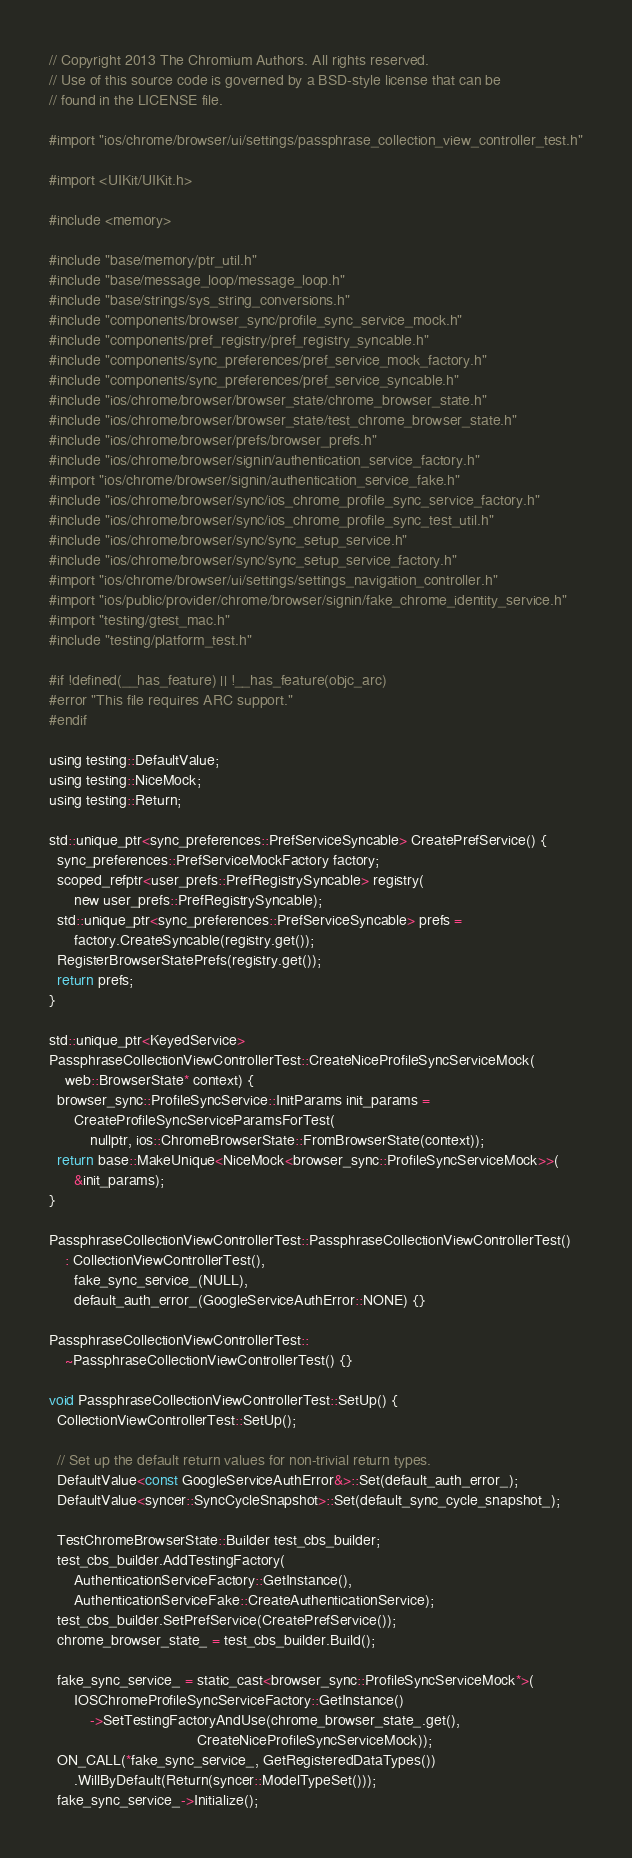<code> <loc_0><loc_0><loc_500><loc_500><_ObjectiveC_>// Copyright 2013 The Chromium Authors. All rights reserved.
// Use of this source code is governed by a BSD-style license that can be
// found in the LICENSE file.

#import "ios/chrome/browser/ui/settings/passphrase_collection_view_controller_test.h"

#import <UIKit/UIKit.h>

#include <memory>

#include "base/memory/ptr_util.h"
#include "base/message_loop/message_loop.h"
#include "base/strings/sys_string_conversions.h"
#include "components/browser_sync/profile_sync_service_mock.h"
#include "components/pref_registry/pref_registry_syncable.h"
#include "components/sync_preferences/pref_service_mock_factory.h"
#include "components/sync_preferences/pref_service_syncable.h"
#include "ios/chrome/browser/browser_state/chrome_browser_state.h"
#include "ios/chrome/browser/browser_state/test_chrome_browser_state.h"
#include "ios/chrome/browser/prefs/browser_prefs.h"
#include "ios/chrome/browser/signin/authentication_service_factory.h"
#import "ios/chrome/browser/signin/authentication_service_fake.h"
#include "ios/chrome/browser/sync/ios_chrome_profile_sync_service_factory.h"
#include "ios/chrome/browser/sync/ios_chrome_profile_sync_test_util.h"
#include "ios/chrome/browser/sync/sync_setup_service.h"
#include "ios/chrome/browser/sync/sync_setup_service_factory.h"
#import "ios/chrome/browser/ui/settings/settings_navigation_controller.h"
#import "ios/public/provider/chrome/browser/signin/fake_chrome_identity_service.h"
#import "testing/gtest_mac.h"
#include "testing/platform_test.h"

#if !defined(__has_feature) || !__has_feature(objc_arc)
#error "This file requires ARC support."
#endif

using testing::DefaultValue;
using testing::NiceMock;
using testing::Return;

std::unique_ptr<sync_preferences::PrefServiceSyncable> CreatePrefService() {
  sync_preferences::PrefServiceMockFactory factory;
  scoped_refptr<user_prefs::PrefRegistrySyncable> registry(
      new user_prefs::PrefRegistrySyncable);
  std::unique_ptr<sync_preferences::PrefServiceSyncable> prefs =
      factory.CreateSyncable(registry.get());
  RegisterBrowserStatePrefs(registry.get());
  return prefs;
}

std::unique_ptr<KeyedService>
PassphraseCollectionViewControllerTest::CreateNiceProfileSyncServiceMock(
    web::BrowserState* context) {
  browser_sync::ProfileSyncService::InitParams init_params =
      CreateProfileSyncServiceParamsForTest(
          nullptr, ios::ChromeBrowserState::FromBrowserState(context));
  return base::MakeUnique<NiceMock<browser_sync::ProfileSyncServiceMock>>(
      &init_params);
}

PassphraseCollectionViewControllerTest::PassphraseCollectionViewControllerTest()
    : CollectionViewControllerTest(),
      fake_sync_service_(NULL),
      default_auth_error_(GoogleServiceAuthError::NONE) {}

PassphraseCollectionViewControllerTest::
    ~PassphraseCollectionViewControllerTest() {}

void PassphraseCollectionViewControllerTest::SetUp() {
  CollectionViewControllerTest::SetUp();

  // Set up the default return values for non-trivial return types.
  DefaultValue<const GoogleServiceAuthError&>::Set(default_auth_error_);
  DefaultValue<syncer::SyncCycleSnapshot>::Set(default_sync_cycle_snapshot_);

  TestChromeBrowserState::Builder test_cbs_builder;
  test_cbs_builder.AddTestingFactory(
      AuthenticationServiceFactory::GetInstance(),
      AuthenticationServiceFake::CreateAuthenticationService);
  test_cbs_builder.SetPrefService(CreatePrefService());
  chrome_browser_state_ = test_cbs_builder.Build();

  fake_sync_service_ = static_cast<browser_sync::ProfileSyncServiceMock*>(
      IOSChromeProfileSyncServiceFactory::GetInstance()
          ->SetTestingFactoryAndUse(chrome_browser_state_.get(),
                                    CreateNiceProfileSyncServiceMock));
  ON_CALL(*fake_sync_service_, GetRegisteredDataTypes())
      .WillByDefault(Return(syncer::ModelTypeSet()));
  fake_sync_service_->Initialize();
</code> 